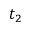<formula> <loc_0><loc_0><loc_500><loc_500>t _ { 2 }</formula> 